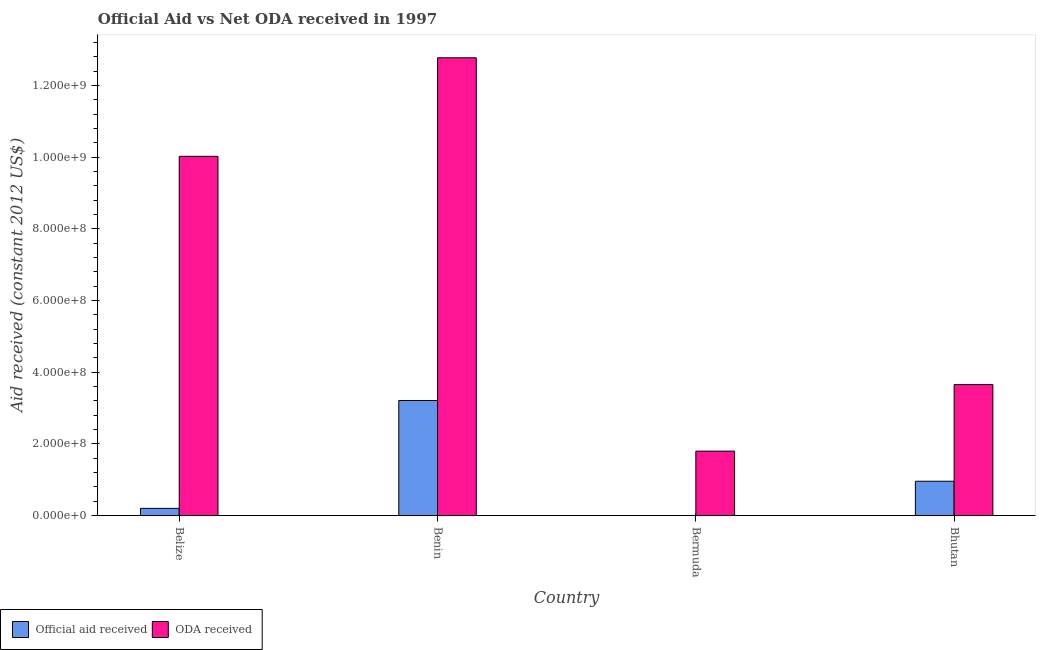How many bars are there on the 4th tick from the left?
Make the answer very short. 2. How many bars are there on the 4th tick from the right?
Provide a succinct answer. 2. What is the label of the 1st group of bars from the left?
Ensure brevity in your answer.  Belize. What is the oda received in Benin?
Give a very brief answer. 1.28e+09. Across all countries, what is the maximum oda received?
Provide a short and direct response. 1.28e+09. Across all countries, what is the minimum oda received?
Your answer should be compact. 1.80e+08. In which country was the oda received maximum?
Provide a succinct answer. Benin. What is the total oda received in the graph?
Provide a succinct answer. 2.83e+09. What is the difference between the oda received in Belize and that in Bermuda?
Give a very brief answer. 8.23e+08. What is the difference between the oda received in Bermuda and the official aid received in Belize?
Your response must be concise. 1.60e+08. What is the average official aid received per country?
Keep it short and to the point. 1.09e+08. What is the difference between the oda received and official aid received in Belize?
Provide a succinct answer. 9.82e+08. What is the ratio of the oda received in Benin to that in Bermuda?
Provide a succinct answer. 7.1. Is the difference between the official aid received in Belize and Bhutan greater than the difference between the oda received in Belize and Bhutan?
Ensure brevity in your answer.  No. What is the difference between the highest and the second highest official aid received?
Your answer should be compact. 2.25e+08. What is the difference between the highest and the lowest official aid received?
Provide a succinct answer. 3.21e+08. In how many countries, is the official aid received greater than the average official aid received taken over all countries?
Your answer should be very brief. 1. Is the sum of the oda received in Bermuda and Bhutan greater than the maximum official aid received across all countries?
Make the answer very short. Yes. How many countries are there in the graph?
Your response must be concise. 4. Are the values on the major ticks of Y-axis written in scientific E-notation?
Your response must be concise. Yes. How many legend labels are there?
Give a very brief answer. 2. How are the legend labels stacked?
Give a very brief answer. Horizontal. What is the title of the graph?
Make the answer very short. Official Aid vs Net ODA received in 1997 . Does "Secondary education" appear as one of the legend labels in the graph?
Keep it short and to the point. No. What is the label or title of the X-axis?
Offer a terse response. Country. What is the label or title of the Y-axis?
Your answer should be compact. Aid received (constant 2012 US$). What is the Aid received (constant 2012 US$) in Official aid received in Belize?
Your answer should be very brief. 2.03e+07. What is the Aid received (constant 2012 US$) of ODA received in Belize?
Offer a very short reply. 1.00e+09. What is the Aid received (constant 2012 US$) in Official aid received in Benin?
Make the answer very short. 3.21e+08. What is the Aid received (constant 2012 US$) of ODA received in Benin?
Give a very brief answer. 1.28e+09. What is the Aid received (constant 2012 US$) of ODA received in Bermuda?
Your response must be concise. 1.80e+08. What is the Aid received (constant 2012 US$) of Official aid received in Bhutan?
Your response must be concise. 9.60e+07. What is the Aid received (constant 2012 US$) of ODA received in Bhutan?
Make the answer very short. 3.66e+08. Across all countries, what is the maximum Aid received (constant 2012 US$) of Official aid received?
Offer a very short reply. 3.21e+08. Across all countries, what is the maximum Aid received (constant 2012 US$) of ODA received?
Your response must be concise. 1.28e+09. Across all countries, what is the minimum Aid received (constant 2012 US$) of Official aid received?
Offer a terse response. 0. Across all countries, what is the minimum Aid received (constant 2012 US$) of ODA received?
Make the answer very short. 1.80e+08. What is the total Aid received (constant 2012 US$) in Official aid received in the graph?
Make the answer very short. 4.38e+08. What is the total Aid received (constant 2012 US$) in ODA received in the graph?
Your answer should be compact. 2.83e+09. What is the difference between the Aid received (constant 2012 US$) in Official aid received in Belize and that in Benin?
Offer a very short reply. -3.01e+08. What is the difference between the Aid received (constant 2012 US$) of ODA received in Belize and that in Benin?
Give a very brief answer. -2.75e+08. What is the difference between the Aid received (constant 2012 US$) in ODA received in Belize and that in Bermuda?
Your answer should be compact. 8.23e+08. What is the difference between the Aid received (constant 2012 US$) of Official aid received in Belize and that in Bhutan?
Give a very brief answer. -7.57e+07. What is the difference between the Aid received (constant 2012 US$) in ODA received in Belize and that in Bhutan?
Keep it short and to the point. 6.37e+08. What is the difference between the Aid received (constant 2012 US$) in ODA received in Benin and that in Bermuda?
Keep it short and to the point. 1.10e+09. What is the difference between the Aid received (constant 2012 US$) in Official aid received in Benin and that in Bhutan?
Keep it short and to the point. 2.25e+08. What is the difference between the Aid received (constant 2012 US$) in ODA received in Benin and that in Bhutan?
Offer a terse response. 9.12e+08. What is the difference between the Aid received (constant 2012 US$) in ODA received in Bermuda and that in Bhutan?
Make the answer very short. -1.86e+08. What is the difference between the Aid received (constant 2012 US$) in Official aid received in Belize and the Aid received (constant 2012 US$) in ODA received in Benin?
Give a very brief answer. -1.26e+09. What is the difference between the Aid received (constant 2012 US$) of Official aid received in Belize and the Aid received (constant 2012 US$) of ODA received in Bermuda?
Offer a terse response. -1.60e+08. What is the difference between the Aid received (constant 2012 US$) in Official aid received in Belize and the Aid received (constant 2012 US$) in ODA received in Bhutan?
Provide a succinct answer. -3.45e+08. What is the difference between the Aid received (constant 2012 US$) in Official aid received in Benin and the Aid received (constant 2012 US$) in ODA received in Bermuda?
Your answer should be very brief. 1.41e+08. What is the difference between the Aid received (constant 2012 US$) of Official aid received in Benin and the Aid received (constant 2012 US$) of ODA received in Bhutan?
Give a very brief answer. -4.44e+07. What is the average Aid received (constant 2012 US$) of Official aid received per country?
Make the answer very short. 1.09e+08. What is the average Aid received (constant 2012 US$) of ODA received per country?
Provide a short and direct response. 7.06e+08. What is the difference between the Aid received (constant 2012 US$) of Official aid received and Aid received (constant 2012 US$) of ODA received in Belize?
Give a very brief answer. -9.82e+08. What is the difference between the Aid received (constant 2012 US$) of Official aid received and Aid received (constant 2012 US$) of ODA received in Benin?
Offer a very short reply. -9.56e+08. What is the difference between the Aid received (constant 2012 US$) of Official aid received and Aid received (constant 2012 US$) of ODA received in Bhutan?
Provide a short and direct response. -2.70e+08. What is the ratio of the Aid received (constant 2012 US$) of Official aid received in Belize to that in Benin?
Offer a terse response. 0.06. What is the ratio of the Aid received (constant 2012 US$) of ODA received in Belize to that in Benin?
Your answer should be very brief. 0.78. What is the ratio of the Aid received (constant 2012 US$) of ODA received in Belize to that in Bermuda?
Give a very brief answer. 5.57. What is the ratio of the Aid received (constant 2012 US$) of Official aid received in Belize to that in Bhutan?
Your response must be concise. 0.21. What is the ratio of the Aid received (constant 2012 US$) in ODA received in Belize to that in Bhutan?
Offer a terse response. 2.74. What is the ratio of the Aid received (constant 2012 US$) of ODA received in Benin to that in Bermuda?
Make the answer very short. 7.1. What is the ratio of the Aid received (constant 2012 US$) of Official aid received in Benin to that in Bhutan?
Offer a terse response. 3.35. What is the ratio of the Aid received (constant 2012 US$) of ODA received in Benin to that in Bhutan?
Keep it short and to the point. 3.49. What is the ratio of the Aid received (constant 2012 US$) of ODA received in Bermuda to that in Bhutan?
Ensure brevity in your answer.  0.49. What is the difference between the highest and the second highest Aid received (constant 2012 US$) in Official aid received?
Your answer should be very brief. 2.25e+08. What is the difference between the highest and the second highest Aid received (constant 2012 US$) of ODA received?
Keep it short and to the point. 2.75e+08. What is the difference between the highest and the lowest Aid received (constant 2012 US$) in Official aid received?
Offer a terse response. 3.21e+08. What is the difference between the highest and the lowest Aid received (constant 2012 US$) in ODA received?
Your answer should be compact. 1.10e+09. 